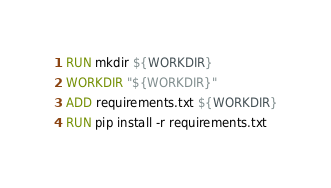<code> <loc_0><loc_0><loc_500><loc_500><_Dockerfile_>RUN mkdir ${WORKDIR}
WORKDIR "${WORKDIR}"
ADD requirements.txt ${WORKDIR}
RUN pip install -r requirements.txt
</code> 